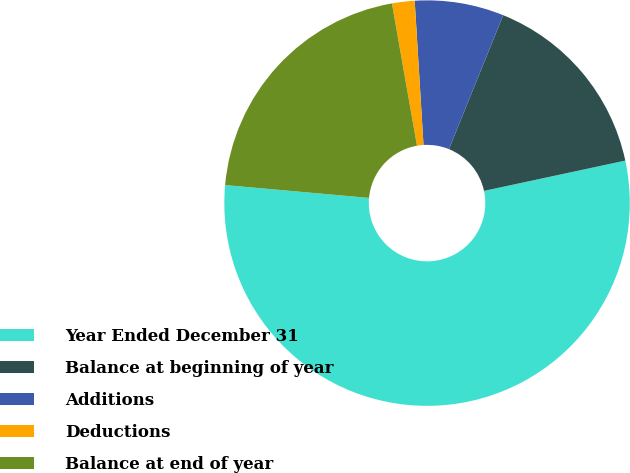Convert chart. <chart><loc_0><loc_0><loc_500><loc_500><pie_chart><fcel>Year Ended December 31<fcel>Balance at beginning of year<fcel>Additions<fcel>Deductions<fcel>Balance at end of year<nl><fcel>54.78%<fcel>15.51%<fcel>7.1%<fcel>1.8%<fcel>20.81%<nl></chart> 